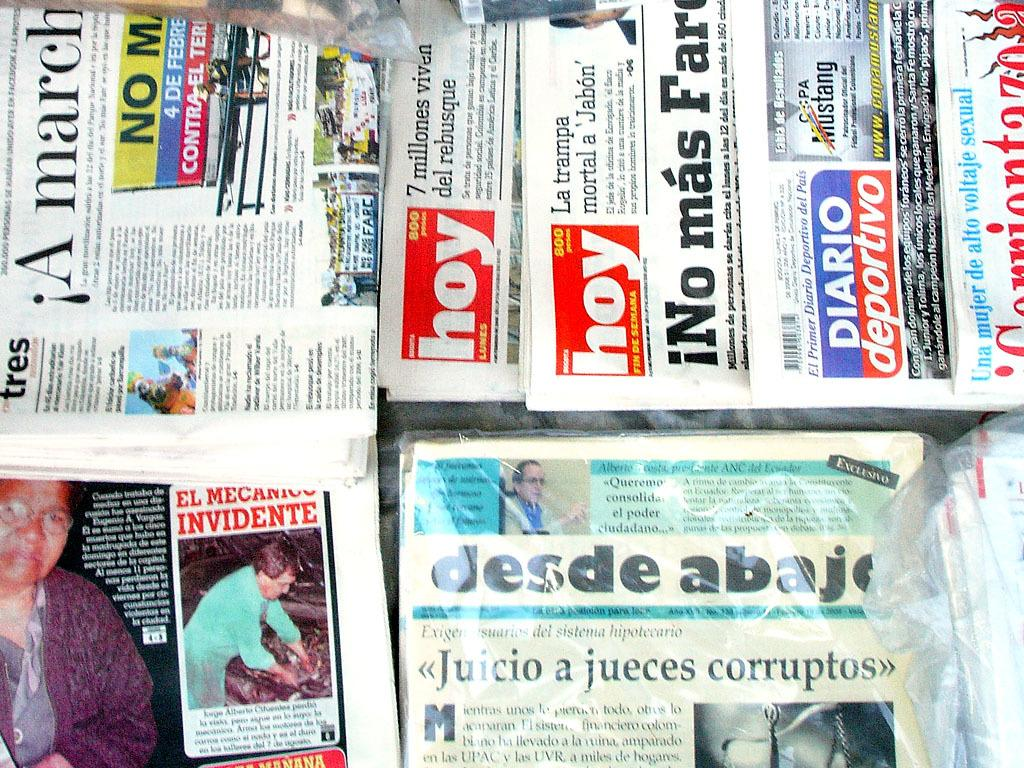<image>
Give a short and clear explanation of the subsequent image. The daily newspaper in Mexico show different news articles. 